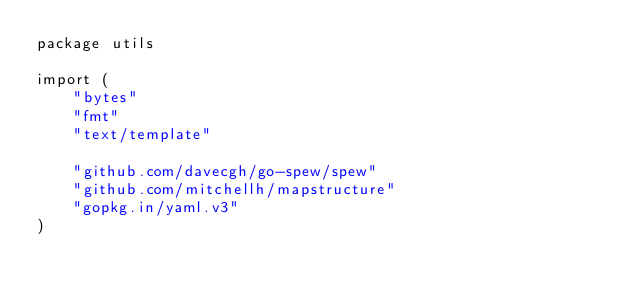<code> <loc_0><loc_0><loc_500><loc_500><_Go_>package utils

import (
	"bytes"
	"fmt"
	"text/template"

	"github.com/davecgh/go-spew/spew"
	"github.com/mitchellh/mapstructure"
	"gopkg.in/yaml.v3"
)
</code> 